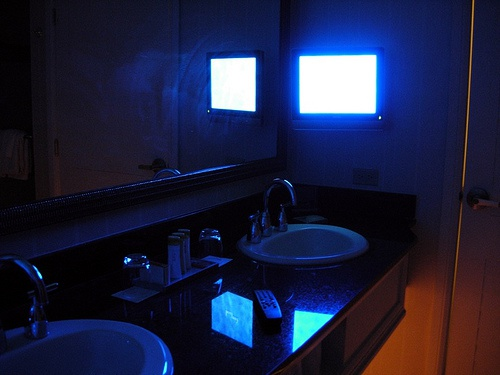Describe the objects in this image and their specific colors. I can see sink in black, navy, darkblue, and blue tones, tv in black, white, blue, and darkblue tones, tv in black, white, navy, darkblue, and blue tones, cup in black, navy, darkblue, and blue tones, and cup in black, navy, darkblue, and blue tones in this image. 